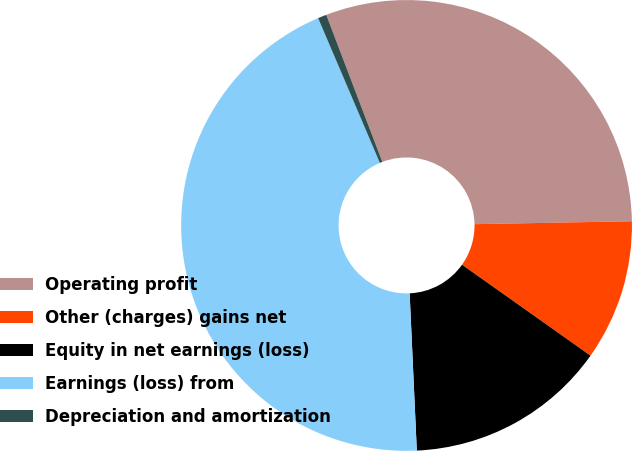Convert chart to OTSL. <chart><loc_0><loc_0><loc_500><loc_500><pie_chart><fcel>Operating profit<fcel>Other (charges) gains net<fcel>Equity in net earnings (loss)<fcel>Earnings (loss) from<fcel>Depreciation and amortization<nl><fcel>30.5%<fcel>10.1%<fcel>14.47%<fcel>44.31%<fcel>0.62%<nl></chart> 